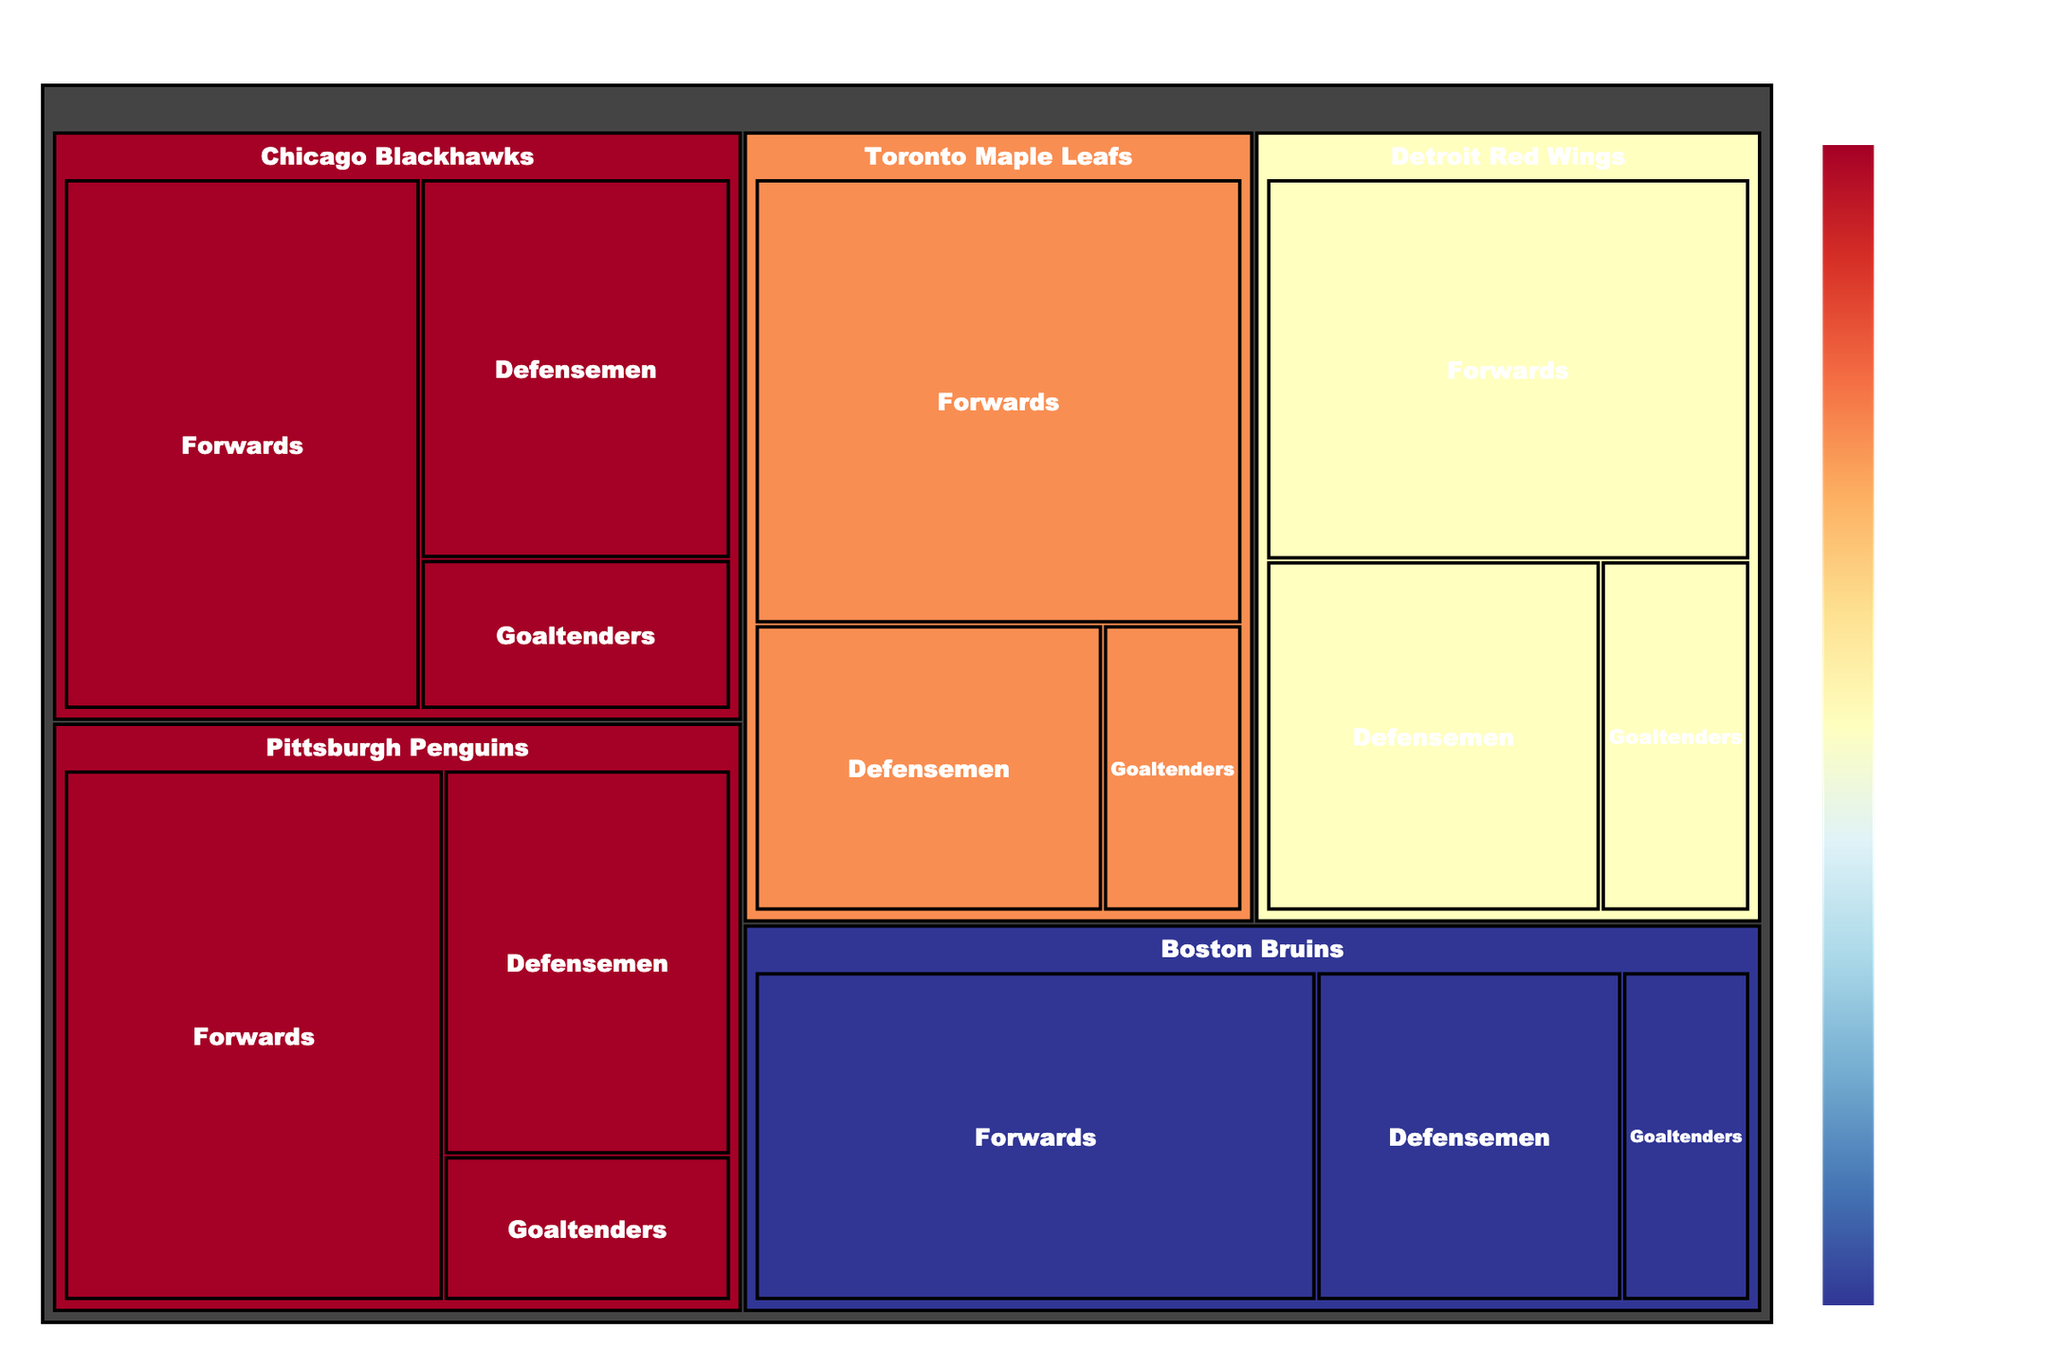Who has the highest salary allocation for forwards? The treemap shows that the Toronto Maple Leafs allocate $43,500,000 to their forwards, which is the highest among all teams.
Answer: Toronto Maple Leafs Which team allocates the least to goaltenders? Based on the treemap, the Toronto Maple Leafs allocate $8,000,000 to their goaltenders, which is the lowest among all teams.
Answer: Toronto Maple Leafs What is the title of the treemap? The title prominently displayed at the top of the treemap reads "NHL Teams Salary Cap Distribution".
Answer: NHL Teams Salary Cap Distribution How much more does Chicago Blackhawks allocate to their forwards compared to their defensemen? Chicago Blackhawks allocate $38,500,000 to their forwards and $24,000,000 to their defensemen. The difference is $38,500,000 - $24,000,000 = $14,500,000.
Answer: $14,500,000 Which team has the most balanced salary distribution across all three player roles? The Boston Bruins have a relatively balanced allocation with $39,500,000 for forwards, $21,500,000 for defensemen, and $9,000,000 for goaltenders. This is less skewed than other teams' distributions.
Answer: Boston Bruins Which team has the highest total salary expenditure? By comparing the color shading representing total salary expenditure, the Toronto Maple Leafs with a dark shade allocate the most in total.
Answer: Toronto Maple Leafs What is the combined salary allocation for Detroit Red Wings' defensemen and goaltenders? The Detroit Red Wings allocate $23,500,000 to defensemen and $10,500,000 to goaltenders. The combined amount is $23,500,000 + $10,500,000 = $34,000,000.
Answer: $34,000,000 How does the salary allocation for Pittsburgh Penguins' forwards compare with that of Boston Bruins' forwards? The Pittsburgh Penguins allocate $41,000,000 to their forwards, whereas the Boston Bruins allocate $39,500,000. Pittsburgh Penguins allocate $1,500,000 more.
Answer: Pittsburgh Penguins Which role generally receives the highest salary allocations across teams? Observing the size and allocation values in the treemap, forwards generally receive the highest salary allocations across all teams depicted.
Answer: Forwards Is there any team with an equal salary allocation among any two roles? No, the treemap shows that there is no team with equal salary allocation among any two roles; all allocations are distinct.
Answer: No 